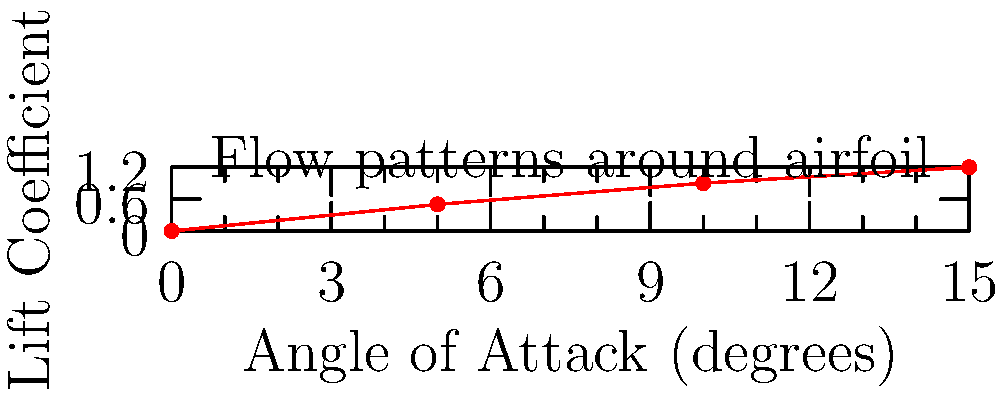Given the graph showing the relationship between the angle of attack and lift coefficient for an airfoil, what phenomenon is likely to occur if the angle of attack is increased beyond the range shown in the plot? How might this impact the flow patterns around the airfoil? To answer this question, let's analyze the graph and consider the aerodynamics of airfoils:

1. The graph shows a positive correlation between the angle of attack and lift coefficient up to 15 degrees.

2. This relationship is typical for airfoils, where increasing the angle of attack generally increases lift.

3. However, this trend cannot continue indefinitely. At a certain point, known as the critical angle of attack, the airflow can no longer follow the upper surface of the airfoil.

4. When this occurs, flow separation begins, leading to a phenomenon called stall.

5. During stall:
   a) The lift coefficient rapidly decreases
   b) Drag increases significantly
   c) Flow patterns change dramatically

6. In terms of flow patterns:
   a) Before stall: Smooth laminar flow over the airfoil
   b) At stall onset: Flow separation begins at the trailing edge
   c) Full stall: Large-scale separation and formation of vortices

7. The exact angle at which stall occurs depends on various factors, including the airfoil shape and Reynolds number.

8. For most airfoils, stall typically occurs between 15-20 degrees angle of attack.

Given that the graph only shows up to 15 degrees, it's likely that increasing the angle of attack further would lead to stall conditions, dramatically altering the flow patterns around the airfoil.
Answer: Stall, causing flow separation and vortex formation. 